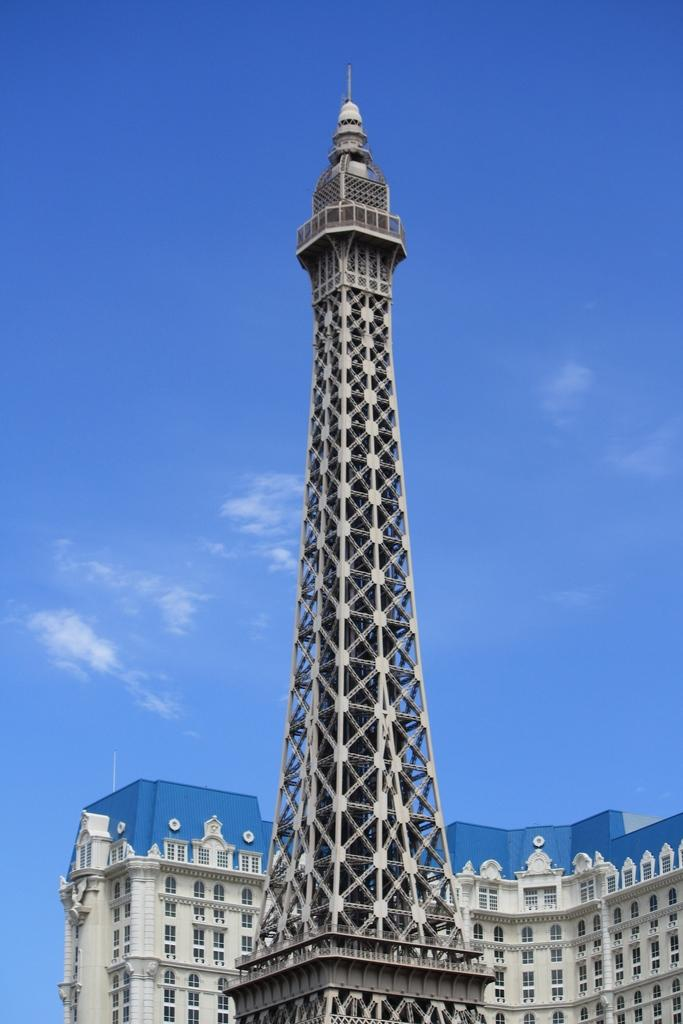What is the main structure in the center of the image? There is a tower in the center of the image. What other structure can be seen behind the tower? There is a building behind the tower. What is visible at the top of the image? The sky is visible at the top of the image. What type of hen can be seen laying bread in the afternoon in the image? There is no hen or bread present in the image, and the time of day is not mentioned. 